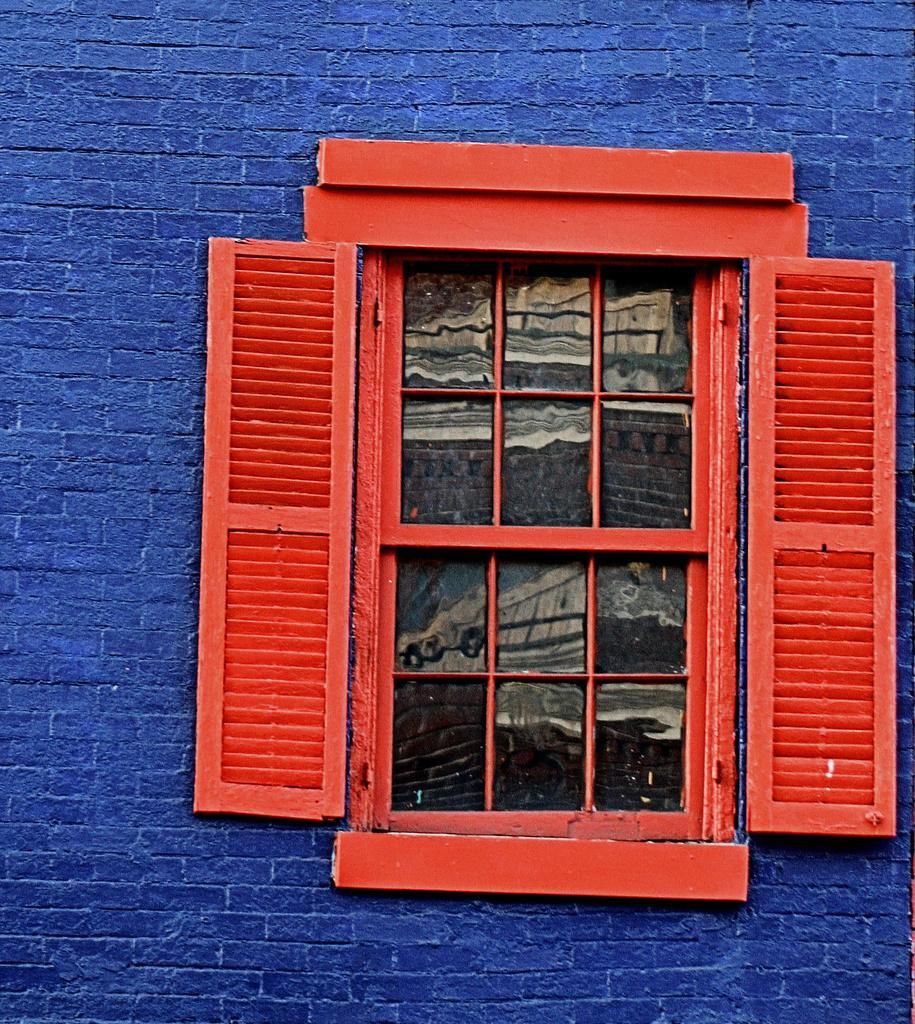Could you give a brief overview of what you see in this image? In this image we can see one big blue wall and one red wooden window with glass. 